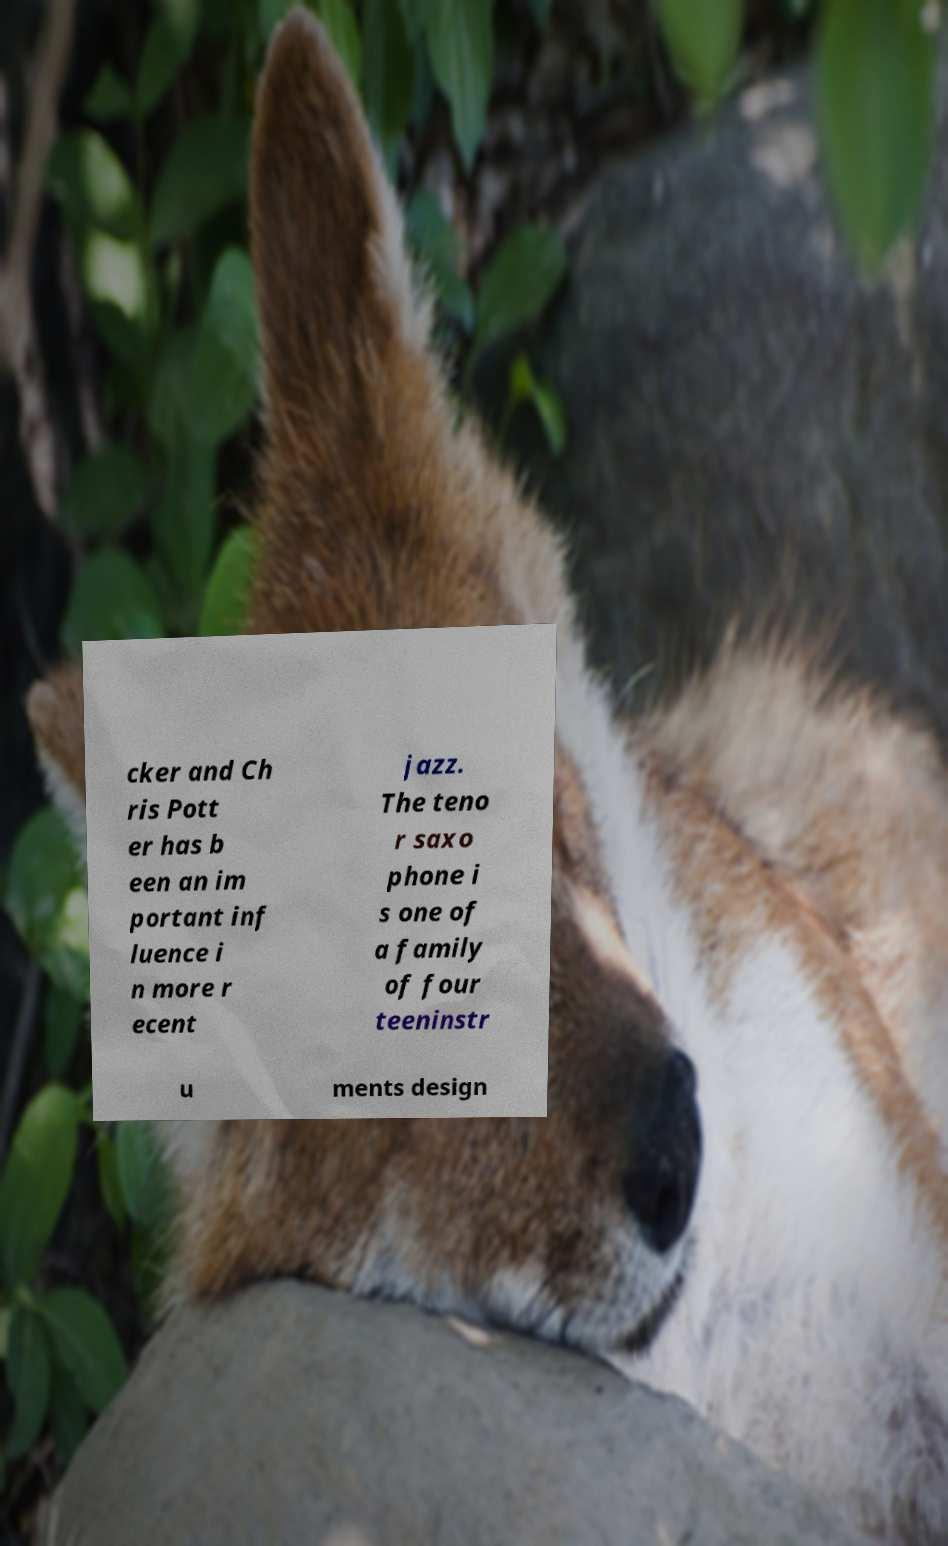I need the written content from this picture converted into text. Can you do that? cker and Ch ris Pott er has b een an im portant inf luence i n more r ecent jazz. The teno r saxo phone i s one of a family of four teeninstr u ments design 